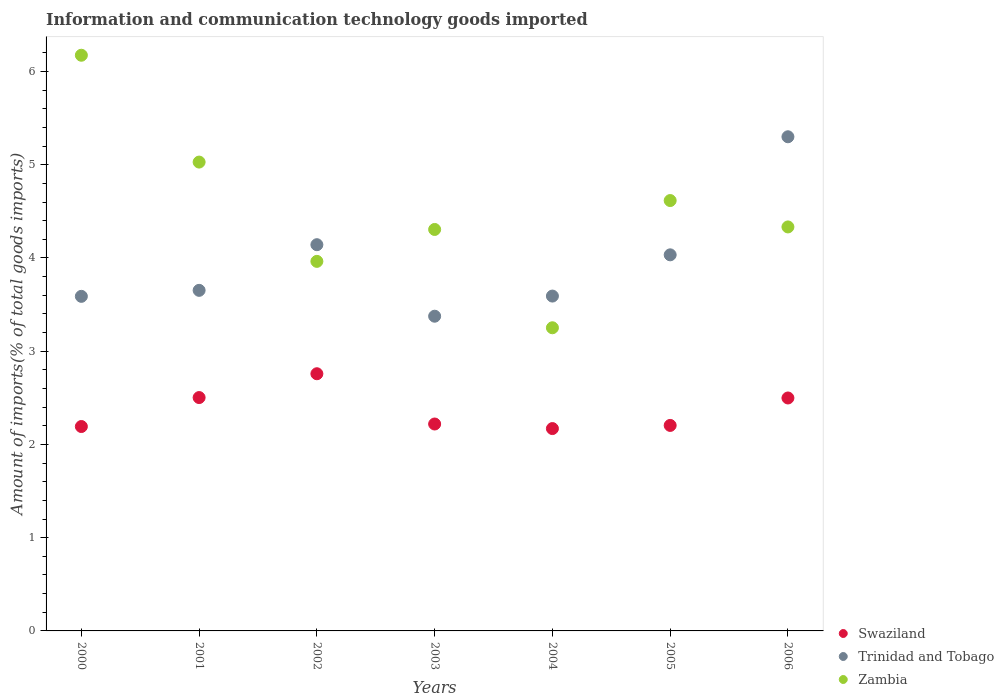How many different coloured dotlines are there?
Your answer should be very brief. 3. What is the amount of goods imported in Zambia in 2005?
Give a very brief answer. 4.62. Across all years, what is the maximum amount of goods imported in Trinidad and Tobago?
Keep it short and to the point. 5.3. Across all years, what is the minimum amount of goods imported in Zambia?
Your response must be concise. 3.25. In which year was the amount of goods imported in Zambia minimum?
Provide a short and direct response. 2004. What is the total amount of goods imported in Swaziland in the graph?
Your answer should be compact. 16.55. What is the difference between the amount of goods imported in Trinidad and Tobago in 2002 and that in 2003?
Give a very brief answer. 0.77. What is the difference between the amount of goods imported in Zambia in 2004 and the amount of goods imported in Swaziland in 2001?
Provide a short and direct response. 0.75. What is the average amount of goods imported in Zambia per year?
Make the answer very short. 4.52. In the year 2004, what is the difference between the amount of goods imported in Zambia and amount of goods imported in Trinidad and Tobago?
Offer a terse response. -0.34. What is the ratio of the amount of goods imported in Zambia in 2003 to that in 2004?
Offer a very short reply. 1.32. What is the difference between the highest and the second highest amount of goods imported in Zambia?
Offer a terse response. 1.15. What is the difference between the highest and the lowest amount of goods imported in Zambia?
Provide a succinct answer. 2.92. In how many years, is the amount of goods imported in Swaziland greater than the average amount of goods imported in Swaziland taken over all years?
Keep it short and to the point. 3. Is the amount of goods imported in Zambia strictly greater than the amount of goods imported in Trinidad and Tobago over the years?
Make the answer very short. No. Is the amount of goods imported in Trinidad and Tobago strictly less than the amount of goods imported in Zambia over the years?
Your answer should be compact. No. How many years are there in the graph?
Offer a terse response. 7. Are the values on the major ticks of Y-axis written in scientific E-notation?
Ensure brevity in your answer.  No. Where does the legend appear in the graph?
Ensure brevity in your answer.  Bottom right. How are the legend labels stacked?
Your answer should be compact. Vertical. What is the title of the graph?
Your answer should be very brief. Information and communication technology goods imported. Does "Congo (Republic)" appear as one of the legend labels in the graph?
Keep it short and to the point. No. What is the label or title of the Y-axis?
Keep it short and to the point. Amount of imports(% of total goods imports). What is the Amount of imports(% of total goods imports) in Swaziland in 2000?
Offer a terse response. 2.19. What is the Amount of imports(% of total goods imports) in Trinidad and Tobago in 2000?
Ensure brevity in your answer.  3.59. What is the Amount of imports(% of total goods imports) of Zambia in 2000?
Your answer should be compact. 6.17. What is the Amount of imports(% of total goods imports) in Swaziland in 2001?
Your answer should be compact. 2.5. What is the Amount of imports(% of total goods imports) of Trinidad and Tobago in 2001?
Provide a short and direct response. 3.65. What is the Amount of imports(% of total goods imports) of Zambia in 2001?
Keep it short and to the point. 5.03. What is the Amount of imports(% of total goods imports) in Swaziland in 2002?
Your answer should be compact. 2.76. What is the Amount of imports(% of total goods imports) of Trinidad and Tobago in 2002?
Your answer should be very brief. 4.14. What is the Amount of imports(% of total goods imports) in Zambia in 2002?
Give a very brief answer. 3.96. What is the Amount of imports(% of total goods imports) of Swaziland in 2003?
Provide a short and direct response. 2.22. What is the Amount of imports(% of total goods imports) in Trinidad and Tobago in 2003?
Offer a terse response. 3.38. What is the Amount of imports(% of total goods imports) of Zambia in 2003?
Ensure brevity in your answer.  4.31. What is the Amount of imports(% of total goods imports) in Swaziland in 2004?
Keep it short and to the point. 2.17. What is the Amount of imports(% of total goods imports) in Trinidad and Tobago in 2004?
Give a very brief answer. 3.59. What is the Amount of imports(% of total goods imports) in Zambia in 2004?
Make the answer very short. 3.25. What is the Amount of imports(% of total goods imports) of Swaziland in 2005?
Your answer should be compact. 2.2. What is the Amount of imports(% of total goods imports) in Trinidad and Tobago in 2005?
Ensure brevity in your answer.  4.03. What is the Amount of imports(% of total goods imports) in Zambia in 2005?
Give a very brief answer. 4.62. What is the Amount of imports(% of total goods imports) of Swaziland in 2006?
Provide a short and direct response. 2.5. What is the Amount of imports(% of total goods imports) in Trinidad and Tobago in 2006?
Ensure brevity in your answer.  5.3. What is the Amount of imports(% of total goods imports) of Zambia in 2006?
Offer a terse response. 4.33. Across all years, what is the maximum Amount of imports(% of total goods imports) in Swaziland?
Make the answer very short. 2.76. Across all years, what is the maximum Amount of imports(% of total goods imports) in Trinidad and Tobago?
Your response must be concise. 5.3. Across all years, what is the maximum Amount of imports(% of total goods imports) in Zambia?
Your answer should be very brief. 6.17. Across all years, what is the minimum Amount of imports(% of total goods imports) in Swaziland?
Give a very brief answer. 2.17. Across all years, what is the minimum Amount of imports(% of total goods imports) in Trinidad and Tobago?
Make the answer very short. 3.38. Across all years, what is the minimum Amount of imports(% of total goods imports) of Zambia?
Ensure brevity in your answer.  3.25. What is the total Amount of imports(% of total goods imports) in Swaziland in the graph?
Provide a succinct answer. 16.55. What is the total Amount of imports(% of total goods imports) in Trinidad and Tobago in the graph?
Make the answer very short. 27.68. What is the total Amount of imports(% of total goods imports) of Zambia in the graph?
Your answer should be very brief. 31.67. What is the difference between the Amount of imports(% of total goods imports) in Swaziland in 2000 and that in 2001?
Keep it short and to the point. -0.31. What is the difference between the Amount of imports(% of total goods imports) in Trinidad and Tobago in 2000 and that in 2001?
Offer a terse response. -0.06. What is the difference between the Amount of imports(% of total goods imports) in Zambia in 2000 and that in 2001?
Offer a terse response. 1.15. What is the difference between the Amount of imports(% of total goods imports) of Swaziland in 2000 and that in 2002?
Your response must be concise. -0.57. What is the difference between the Amount of imports(% of total goods imports) in Trinidad and Tobago in 2000 and that in 2002?
Your answer should be very brief. -0.55. What is the difference between the Amount of imports(% of total goods imports) of Zambia in 2000 and that in 2002?
Your response must be concise. 2.21. What is the difference between the Amount of imports(% of total goods imports) of Swaziland in 2000 and that in 2003?
Provide a succinct answer. -0.03. What is the difference between the Amount of imports(% of total goods imports) in Trinidad and Tobago in 2000 and that in 2003?
Keep it short and to the point. 0.21. What is the difference between the Amount of imports(% of total goods imports) of Zambia in 2000 and that in 2003?
Your answer should be compact. 1.87. What is the difference between the Amount of imports(% of total goods imports) in Swaziland in 2000 and that in 2004?
Provide a short and direct response. 0.02. What is the difference between the Amount of imports(% of total goods imports) in Trinidad and Tobago in 2000 and that in 2004?
Provide a short and direct response. -0. What is the difference between the Amount of imports(% of total goods imports) of Zambia in 2000 and that in 2004?
Make the answer very short. 2.92. What is the difference between the Amount of imports(% of total goods imports) of Swaziland in 2000 and that in 2005?
Give a very brief answer. -0.01. What is the difference between the Amount of imports(% of total goods imports) in Trinidad and Tobago in 2000 and that in 2005?
Offer a very short reply. -0.45. What is the difference between the Amount of imports(% of total goods imports) of Zambia in 2000 and that in 2005?
Your response must be concise. 1.56. What is the difference between the Amount of imports(% of total goods imports) in Swaziland in 2000 and that in 2006?
Keep it short and to the point. -0.31. What is the difference between the Amount of imports(% of total goods imports) of Trinidad and Tobago in 2000 and that in 2006?
Provide a succinct answer. -1.71. What is the difference between the Amount of imports(% of total goods imports) of Zambia in 2000 and that in 2006?
Ensure brevity in your answer.  1.84. What is the difference between the Amount of imports(% of total goods imports) of Swaziland in 2001 and that in 2002?
Your answer should be compact. -0.26. What is the difference between the Amount of imports(% of total goods imports) in Trinidad and Tobago in 2001 and that in 2002?
Your answer should be compact. -0.49. What is the difference between the Amount of imports(% of total goods imports) of Zambia in 2001 and that in 2002?
Ensure brevity in your answer.  1.06. What is the difference between the Amount of imports(% of total goods imports) of Swaziland in 2001 and that in 2003?
Provide a succinct answer. 0.28. What is the difference between the Amount of imports(% of total goods imports) in Trinidad and Tobago in 2001 and that in 2003?
Ensure brevity in your answer.  0.28. What is the difference between the Amount of imports(% of total goods imports) of Zambia in 2001 and that in 2003?
Provide a short and direct response. 0.72. What is the difference between the Amount of imports(% of total goods imports) in Swaziland in 2001 and that in 2004?
Keep it short and to the point. 0.33. What is the difference between the Amount of imports(% of total goods imports) of Trinidad and Tobago in 2001 and that in 2004?
Give a very brief answer. 0.06. What is the difference between the Amount of imports(% of total goods imports) of Zambia in 2001 and that in 2004?
Your answer should be compact. 1.78. What is the difference between the Amount of imports(% of total goods imports) in Swaziland in 2001 and that in 2005?
Ensure brevity in your answer.  0.3. What is the difference between the Amount of imports(% of total goods imports) of Trinidad and Tobago in 2001 and that in 2005?
Offer a terse response. -0.38. What is the difference between the Amount of imports(% of total goods imports) of Zambia in 2001 and that in 2005?
Your answer should be very brief. 0.41. What is the difference between the Amount of imports(% of total goods imports) of Swaziland in 2001 and that in 2006?
Give a very brief answer. 0. What is the difference between the Amount of imports(% of total goods imports) of Trinidad and Tobago in 2001 and that in 2006?
Your response must be concise. -1.65. What is the difference between the Amount of imports(% of total goods imports) in Zambia in 2001 and that in 2006?
Offer a very short reply. 0.7. What is the difference between the Amount of imports(% of total goods imports) of Swaziland in 2002 and that in 2003?
Provide a short and direct response. 0.54. What is the difference between the Amount of imports(% of total goods imports) of Trinidad and Tobago in 2002 and that in 2003?
Your answer should be very brief. 0.77. What is the difference between the Amount of imports(% of total goods imports) of Zambia in 2002 and that in 2003?
Ensure brevity in your answer.  -0.34. What is the difference between the Amount of imports(% of total goods imports) in Swaziland in 2002 and that in 2004?
Provide a short and direct response. 0.59. What is the difference between the Amount of imports(% of total goods imports) in Trinidad and Tobago in 2002 and that in 2004?
Your answer should be compact. 0.55. What is the difference between the Amount of imports(% of total goods imports) in Zambia in 2002 and that in 2004?
Your answer should be very brief. 0.71. What is the difference between the Amount of imports(% of total goods imports) of Swaziland in 2002 and that in 2005?
Give a very brief answer. 0.55. What is the difference between the Amount of imports(% of total goods imports) in Trinidad and Tobago in 2002 and that in 2005?
Your answer should be compact. 0.11. What is the difference between the Amount of imports(% of total goods imports) of Zambia in 2002 and that in 2005?
Your answer should be compact. -0.65. What is the difference between the Amount of imports(% of total goods imports) in Swaziland in 2002 and that in 2006?
Offer a terse response. 0.26. What is the difference between the Amount of imports(% of total goods imports) in Trinidad and Tobago in 2002 and that in 2006?
Give a very brief answer. -1.16. What is the difference between the Amount of imports(% of total goods imports) in Zambia in 2002 and that in 2006?
Your response must be concise. -0.37. What is the difference between the Amount of imports(% of total goods imports) in Swaziland in 2003 and that in 2004?
Your answer should be compact. 0.05. What is the difference between the Amount of imports(% of total goods imports) in Trinidad and Tobago in 2003 and that in 2004?
Your answer should be very brief. -0.22. What is the difference between the Amount of imports(% of total goods imports) of Zambia in 2003 and that in 2004?
Ensure brevity in your answer.  1.05. What is the difference between the Amount of imports(% of total goods imports) in Swaziland in 2003 and that in 2005?
Provide a succinct answer. 0.02. What is the difference between the Amount of imports(% of total goods imports) of Trinidad and Tobago in 2003 and that in 2005?
Your answer should be very brief. -0.66. What is the difference between the Amount of imports(% of total goods imports) of Zambia in 2003 and that in 2005?
Offer a terse response. -0.31. What is the difference between the Amount of imports(% of total goods imports) in Swaziland in 2003 and that in 2006?
Keep it short and to the point. -0.28. What is the difference between the Amount of imports(% of total goods imports) of Trinidad and Tobago in 2003 and that in 2006?
Your answer should be compact. -1.92. What is the difference between the Amount of imports(% of total goods imports) in Zambia in 2003 and that in 2006?
Your answer should be compact. -0.03. What is the difference between the Amount of imports(% of total goods imports) in Swaziland in 2004 and that in 2005?
Your response must be concise. -0.03. What is the difference between the Amount of imports(% of total goods imports) in Trinidad and Tobago in 2004 and that in 2005?
Provide a succinct answer. -0.44. What is the difference between the Amount of imports(% of total goods imports) in Zambia in 2004 and that in 2005?
Give a very brief answer. -1.36. What is the difference between the Amount of imports(% of total goods imports) of Swaziland in 2004 and that in 2006?
Provide a succinct answer. -0.33. What is the difference between the Amount of imports(% of total goods imports) in Trinidad and Tobago in 2004 and that in 2006?
Give a very brief answer. -1.71. What is the difference between the Amount of imports(% of total goods imports) of Zambia in 2004 and that in 2006?
Provide a short and direct response. -1.08. What is the difference between the Amount of imports(% of total goods imports) of Swaziland in 2005 and that in 2006?
Your answer should be very brief. -0.29. What is the difference between the Amount of imports(% of total goods imports) of Trinidad and Tobago in 2005 and that in 2006?
Keep it short and to the point. -1.27. What is the difference between the Amount of imports(% of total goods imports) in Zambia in 2005 and that in 2006?
Ensure brevity in your answer.  0.28. What is the difference between the Amount of imports(% of total goods imports) of Swaziland in 2000 and the Amount of imports(% of total goods imports) of Trinidad and Tobago in 2001?
Ensure brevity in your answer.  -1.46. What is the difference between the Amount of imports(% of total goods imports) in Swaziland in 2000 and the Amount of imports(% of total goods imports) in Zambia in 2001?
Your answer should be compact. -2.84. What is the difference between the Amount of imports(% of total goods imports) in Trinidad and Tobago in 2000 and the Amount of imports(% of total goods imports) in Zambia in 2001?
Your answer should be very brief. -1.44. What is the difference between the Amount of imports(% of total goods imports) of Swaziland in 2000 and the Amount of imports(% of total goods imports) of Trinidad and Tobago in 2002?
Your answer should be compact. -1.95. What is the difference between the Amount of imports(% of total goods imports) of Swaziland in 2000 and the Amount of imports(% of total goods imports) of Zambia in 2002?
Provide a short and direct response. -1.77. What is the difference between the Amount of imports(% of total goods imports) in Trinidad and Tobago in 2000 and the Amount of imports(% of total goods imports) in Zambia in 2002?
Your answer should be compact. -0.38. What is the difference between the Amount of imports(% of total goods imports) of Swaziland in 2000 and the Amount of imports(% of total goods imports) of Trinidad and Tobago in 2003?
Ensure brevity in your answer.  -1.18. What is the difference between the Amount of imports(% of total goods imports) in Swaziland in 2000 and the Amount of imports(% of total goods imports) in Zambia in 2003?
Give a very brief answer. -2.11. What is the difference between the Amount of imports(% of total goods imports) of Trinidad and Tobago in 2000 and the Amount of imports(% of total goods imports) of Zambia in 2003?
Your answer should be compact. -0.72. What is the difference between the Amount of imports(% of total goods imports) in Swaziland in 2000 and the Amount of imports(% of total goods imports) in Trinidad and Tobago in 2004?
Keep it short and to the point. -1.4. What is the difference between the Amount of imports(% of total goods imports) in Swaziland in 2000 and the Amount of imports(% of total goods imports) in Zambia in 2004?
Offer a terse response. -1.06. What is the difference between the Amount of imports(% of total goods imports) of Trinidad and Tobago in 2000 and the Amount of imports(% of total goods imports) of Zambia in 2004?
Keep it short and to the point. 0.34. What is the difference between the Amount of imports(% of total goods imports) in Swaziland in 2000 and the Amount of imports(% of total goods imports) in Trinidad and Tobago in 2005?
Your answer should be very brief. -1.84. What is the difference between the Amount of imports(% of total goods imports) in Swaziland in 2000 and the Amount of imports(% of total goods imports) in Zambia in 2005?
Your answer should be very brief. -2.42. What is the difference between the Amount of imports(% of total goods imports) in Trinidad and Tobago in 2000 and the Amount of imports(% of total goods imports) in Zambia in 2005?
Make the answer very short. -1.03. What is the difference between the Amount of imports(% of total goods imports) of Swaziland in 2000 and the Amount of imports(% of total goods imports) of Trinidad and Tobago in 2006?
Provide a short and direct response. -3.11. What is the difference between the Amount of imports(% of total goods imports) in Swaziland in 2000 and the Amount of imports(% of total goods imports) in Zambia in 2006?
Your answer should be very brief. -2.14. What is the difference between the Amount of imports(% of total goods imports) in Trinidad and Tobago in 2000 and the Amount of imports(% of total goods imports) in Zambia in 2006?
Offer a terse response. -0.74. What is the difference between the Amount of imports(% of total goods imports) of Swaziland in 2001 and the Amount of imports(% of total goods imports) of Trinidad and Tobago in 2002?
Keep it short and to the point. -1.64. What is the difference between the Amount of imports(% of total goods imports) of Swaziland in 2001 and the Amount of imports(% of total goods imports) of Zambia in 2002?
Your answer should be compact. -1.46. What is the difference between the Amount of imports(% of total goods imports) in Trinidad and Tobago in 2001 and the Amount of imports(% of total goods imports) in Zambia in 2002?
Offer a terse response. -0.31. What is the difference between the Amount of imports(% of total goods imports) of Swaziland in 2001 and the Amount of imports(% of total goods imports) of Trinidad and Tobago in 2003?
Provide a succinct answer. -0.87. What is the difference between the Amount of imports(% of total goods imports) of Swaziland in 2001 and the Amount of imports(% of total goods imports) of Zambia in 2003?
Your answer should be compact. -1.8. What is the difference between the Amount of imports(% of total goods imports) of Trinidad and Tobago in 2001 and the Amount of imports(% of total goods imports) of Zambia in 2003?
Your answer should be compact. -0.65. What is the difference between the Amount of imports(% of total goods imports) of Swaziland in 2001 and the Amount of imports(% of total goods imports) of Trinidad and Tobago in 2004?
Provide a short and direct response. -1.09. What is the difference between the Amount of imports(% of total goods imports) of Swaziland in 2001 and the Amount of imports(% of total goods imports) of Zambia in 2004?
Offer a very short reply. -0.75. What is the difference between the Amount of imports(% of total goods imports) in Trinidad and Tobago in 2001 and the Amount of imports(% of total goods imports) in Zambia in 2004?
Offer a very short reply. 0.4. What is the difference between the Amount of imports(% of total goods imports) in Swaziland in 2001 and the Amount of imports(% of total goods imports) in Trinidad and Tobago in 2005?
Provide a short and direct response. -1.53. What is the difference between the Amount of imports(% of total goods imports) in Swaziland in 2001 and the Amount of imports(% of total goods imports) in Zambia in 2005?
Provide a short and direct response. -2.11. What is the difference between the Amount of imports(% of total goods imports) in Trinidad and Tobago in 2001 and the Amount of imports(% of total goods imports) in Zambia in 2005?
Give a very brief answer. -0.96. What is the difference between the Amount of imports(% of total goods imports) in Swaziland in 2001 and the Amount of imports(% of total goods imports) in Trinidad and Tobago in 2006?
Ensure brevity in your answer.  -2.8. What is the difference between the Amount of imports(% of total goods imports) in Swaziland in 2001 and the Amount of imports(% of total goods imports) in Zambia in 2006?
Offer a very short reply. -1.83. What is the difference between the Amount of imports(% of total goods imports) of Trinidad and Tobago in 2001 and the Amount of imports(% of total goods imports) of Zambia in 2006?
Your answer should be very brief. -0.68. What is the difference between the Amount of imports(% of total goods imports) in Swaziland in 2002 and the Amount of imports(% of total goods imports) in Trinidad and Tobago in 2003?
Keep it short and to the point. -0.62. What is the difference between the Amount of imports(% of total goods imports) of Swaziland in 2002 and the Amount of imports(% of total goods imports) of Zambia in 2003?
Offer a very short reply. -1.55. What is the difference between the Amount of imports(% of total goods imports) in Trinidad and Tobago in 2002 and the Amount of imports(% of total goods imports) in Zambia in 2003?
Offer a terse response. -0.16. What is the difference between the Amount of imports(% of total goods imports) in Swaziland in 2002 and the Amount of imports(% of total goods imports) in Trinidad and Tobago in 2004?
Offer a very short reply. -0.83. What is the difference between the Amount of imports(% of total goods imports) of Swaziland in 2002 and the Amount of imports(% of total goods imports) of Zambia in 2004?
Ensure brevity in your answer.  -0.49. What is the difference between the Amount of imports(% of total goods imports) in Trinidad and Tobago in 2002 and the Amount of imports(% of total goods imports) in Zambia in 2004?
Keep it short and to the point. 0.89. What is the difference between the Amount of imports(% of total goods imports) in Swaziland in 2002 and the Amount of imports(% of total goods imports) in Trinidad and Tobago in 2005?
Your answer should be compact. -1.28. What is the difference between the Amount of imports(% of total goods imports) of Swaziland in 2002 and the Amount of imports(% of total goods imports) of Zambia in 2005?
Make the answer very short. -1.86. What is the difference between the Amount of imports(% of total goods imports) in Trinidad and Tobago in 2002 and the Amount of imports(% of total goods imports) in Zambia in 2005?
Provide a succinct answer. -0.47. What is the difference between the Amount of imports(% of total goods imports) in Swaziland in 2002 and the Amount of imports(% of total goods imports) in Trinidad and Tobago in 2006?
Ensure brevity in your answer.  -2.54. What is the difference between the Amount of imports(% of total goods imports) of Swaziland in 2002 and the Amount of imports(% of total goods imports) of Zambia in 2006?
Give a very brief answer. -1.57. What is the difference between the Amount of imports(% of total goods imports) in Trinidad and Tobago in 2002 and the Amount of imports(% of total goods imports) in Zambia in 2006?
Your answer should be very brief. -0.19. What is the difference between the Amount of imports(% of total goods imports) of Swaziland in 2003 and the Amount of imports(% of total goods imports) of Trinidad and Tobago in 2004?
Make the answer very short. -1.37. What is the difference between the Amount of imports(% of total goods imports) of Swaziland in 2003 and the Amount of imports(% of total goods imports) of Zambia in 2004?
Your answer should be compact. -1.03. What is the difference between the Amount of imports(% of total goods imports) of Trinidad and Tobago in 2003 and the Amount of imports(% of total goods imports) of Zambia in 2004?
Provide a short and direct response. 0.12. What is the difference between the Amount of imports(% of total goods imports) of Swaziland in 2003 and the Amount of imports(% of total goods imports) of Trinidad and Tobago in 2005?
Ensure brevity in your answer.  -1.81. What is the difference between the Amount of imports(% of total goods imports) of Swaziland in 2003 and the Amount of imports(% of total goods imports) of Zambia in 2005?
Your answer should be compact. -2.4. What is the difference between the Amount of imports(% of total goods imports) of Trinidad and Tobago in 2003 and the Amount of imports(% of total goods imports) of Zambia in 2005?
Give a very brief answer. -1.24. What is the difference between the Amount of imports(% of total goods imports) in Swaziland in 2003 and the Amount of imports(% of total goods imports) in Trinidad and Tobago in 2006?
Provide a succinct answer. -3.08. What is the difference between the Amount of imports(% of total goods imports) in Swaziland in 2003 and the Amount of imports(% of total goods imports) in Zambia in 2006?
Your response must be concise. -2.11. What is the difference between the Amount of imports(% of total goods imports) in Trinidad and Tobago in 2003 and the Amount of imports(% of total goods imports) in Zambia in 2006?
Your response must be concise. -0.96. What is the difference between the Amount of imports(% of total goods imports) in Swaziland in 2004 and the Amount of imports(% of total goods imports) in Trinidad and Tobago in 2005?
Your answer should be compact. -1.86. What is the difference between the Amount of imports(% of total goods imports) of Swaziland in 2004 and the Amount of imports(% of total goods imports) of Zambia in 2005?
Ensure brevity in your answer.  -2.45. What is the difference between the Amount of imports(% of total goods imports) of Trinidad and Tobago in 2004 and the Amount of imports(% of total goods imports) of Zambia in 2005?
Offer a very short reply. -1.02. What is the difference between the Amount of imports(% of total goods imports) of Swaziland in 2004 and the Amount of imports(% of total goods imports) of Trinidad and Tobago in 2006?
Your answer should be compact. -3.13. What is the difference between the Amount of imports(% of total goods imports) in Swaziland in 2004 and the Amount of imports(% of total goods imports) in Zambia in 2006?
Ensure brevity in your answer.  -2.16. What is the difference between the Amount of imports(% of total goods imports) in Trinidad and Tobago in 2004 and the Amount of imports(% of total goods imports) in Zambia in 2006?
Give a very brief answer. -0.74. What is the difference between the Amount of imports(% of total goods imports) of Swaziland in 2005 and the Amount of imports(% of total goods imports) of Trinidad and Tobago in 2006?
Your answer should be compact. -3.1. What is the difference between the Amount of imports(% of total goods imports) of Swaziland in 2005 and the Amount of imports(% of total goods imports) of Zambia in 2006?
Offer a terse response. -2.13. What is the difference between the Amount of imports(% of total goods imports) in Trinidad and Tobago in 2005 and the Amount of imports(% of total goods imports) in Zambia in 2006?
Provide a short and direct response. -0.3. What is the average Amount of imports(% of total goods imports) of Swaziland per year?
Offer a very short reply. 2.36. What is the average Amount of imports(% of total goods imports) of Trinidad and Tobago per year?
Provide a succinct answer. 3.95. What is the average Amount of imports(% of total goods imports) in Zambia per year?
Provide a short and direct response. 4.52. In the year 2000, what is the difference between the Amount of imports(% of total goods imports) of Swaziland and Amount of imports(% of total goods imports) of Trinidad and Tobago?
Your answer should be compact. -1.4. In the year 2000, what is the difference between the Amount of imports(% of total goods imports) in Swaziland and Amount of imports(% of total goods imports) in Zambia?
Provide a short and direct response. -3.98. In the year 2000, what is the difference between the Amount of imports(% of total goods imports) of Trinidad and Tobago and Amount of imports(% of total goods imports) of Zambia?
Provide a succinct answer. -2.59. In the year 2001, what is the difference between the Amount of imports(% of total goods imports) of Swaziland and Amount of imports(% of total goods imports) of Trinidad and Tobago?
Your answer should be very brief. -1.15. In the year 2001, what is the difference between the Amount of imports(% of total goods imports) in Swaziland and Amount of imports(% of total goods imports) in Zambia?
Your answer should be compact. -2.53. In the year 2001, what is the difference between the Amount of imports(% of total goods imports) of Trinidad and Tobago and Amount of imports(% of total goods imports) of Zambia?
Offer a very short reply. -1.38. In the year 2002, what is the difference between the Amount of imports(% of total goods imports) in Swaziland and Amount of imports(% of total goods imports) in Trinidad and Tobago?
Your answer should be compact. -1.38. In the year 2002, what is the difference between the Amount of imports(% of total goods imports) in Swaziland and Amount of imports(% of total goods imports) in Zambia?
Offer a very short reply. -1.21. In the year 2002, what is the difference between the Amount of imports(% of total goods imports) of Trinidad and Tobago and Amount of imports(% of total goods imports) of Zambia?
Your answer should be very brief. 0.18. In the year 2003, what is the difference between the Amount of imports(% of total goods imports) in Swaziland and Amount of imports(% of total goods imports) in Trinidad and Tobago?
Provide a succinct answer. -1.16. In the year 2003, what is the difference between the Amount of imports(% of total goods imports) in Swaziland and Amount of imports(% of total goods imports) in Zambia?
Provide a succinct answer. -2.09. In the year 2003, what is the difference between the Amount of imports(% of total goods imports) of Trinidad and Tobago and Amount of imports(% of total goods imports) of Zambia?
Provide a succinct answer. -0.93. In the year 2004, what is the difference between the Amount of imports(% of total goods imports) of Swaziland and Amount of imports(% of total goods imports) of Trinidad and Tobago?
Make the answer very short. -1.42. In the year 2004, what is the difference between the Amount of imports(% of total goods imports) of Swaziland and Amount of imports(% of total goods imports) of Zambia?
Your response must be concise. -1.08. In the year 2004, what is the difference between the Amount of imports(% of total goods imports) in Trinidad and Tobago and Amount of imports(% of total goods imports) in Zambia?
Your response must be concise. 0.34. In the year 2005, what is the difference between the Amount of imports(% of total goods imports) of Swaziland and Amount of imports(% of total goods imports) of Trinidad and Tobago?
Your answer should be compact. -1.83. In the year 2005, what is the difference between the Amount of imports(% of total goods imports) of Swaziland and Amount of imports(% of total goods imports) of Zambia?
Give a very brief answer. -2.41. In the year 2005, what is the difference between the Amount of imports(% of total goods imports) of Trinidad and Tobago and Amount of imports(% of total goods imports) of Zambia?
Provide a short and direct response. -0.58. In the year 2006, what is the difference between the Amount of imports(% of total goods imports) of Swaziland and Amount of imports(% of total goods imports) of Trinidad and Tobago?
Your answer should be compact. -2.8. In the year 2006, what is the difference between the Amount of imports(% of total goods imports) in Swaziland and Amount of imports(% of total goods imports) in Zambia?
Make the answer very short. -1.83. In the year 2006, what is the difference between the Amount of imports(% of total goods imports) of Trinidad and Tobago and Amount of imports(% of total goods imports) of Zambia?
Offer a terse response. 0.97. What is the ratio of the Amount of imports(% of total goods imports) of Swaziland in 2000 to that in 2001?
Make the answer very short. 0.88. What is the ratio of the Amount of imports(% of total goods imports) in Trinidad and Tobago in 2000 to that in 2001?
Your answer should be compact. 0.98. What is the ratio of the Amount of imports(% of total goods imports) of Zambia in 2000 to that in 2001?
Give a very brief answer. 1.23. What is the ratio of the Amount of imports(% of total goods imports) of Swaziland in 2000 to that in 2002?
Give a very brief answer. 0.79. What is the ratio of the Amount of imports(% of total goods imports) in Trinidad and Tobago in 2000 to that in 2002?
Provide a short and direct response. 0.87. What is the ratio of the Amount of imports(% of total goods imports) in Zambia in 2000 to that in 2002?
Your answer should be compact. 1.56. What is the ratio of the Amount of imports(% of total goods imports) of Trinidad and Tobago in 2000 to that in 2003?
Offer a terse response. 1.06. What is the ratio of the Amount of imports(% of total goods imports) in Zambia in 2000 to that in 2003?
Keep it short and to the point. 1.43. What is the ratio of the Amount of imports(% of total goods imports) in Swaziland in 2000 to that in 2004?
Offer a terse response. 1.01. What is the ratio of the Amount of imports(% of total goods imports) in Zambia in 2000 to that in 2004?
Your answer should be compact. 1.9. What is the ratio of the Amount of imports(% of total goods imports) of Swaziland in 2000 to that in 2005?
Your response must be concise. 0.99. What is the ratio of the Amount of imports(% of total goods imports) in Trinidad and Tobago in 2000 to that in 2005?
Keep it short and to the point. 0.89. What is the ratio of the Amount of imports(% of total goods imports) of Zambia in 2000 to that in 2005?
Provide a short and direct response. 1.34. What is the ratio of the Amount of imports(% of total goods imports) of Swaziland in 2000 to that in 2006?
Give a very brief answer. 0.88. What is the ratio of the Amount of imports(% of total goods imports) of Trinidad and Tobago in 2000 to that in 2006?
Ensure brevity in your answer.  0.68. What is the ratio of the Amount of imports(% of total goods imports) of Zambia in 2000 to that in 2006?
Provide a short and direct response. 1.43. What is the ratio of the Amount of imports(% of total goods imports) in Swaziland in 2001 to that in 2002?
Make the answer very short. 0.91. What is the ratio of the Amount of imports(% of total goods imports) of Trinidad and Tobago in 2001 to that in 2002?
Your answer should be compact. 0.88. What is the ratio of the Amount of imports(% of total goods imports) in Zambia in 2001 to that in 2002?
Keep it short and to the point. 1.27. What is the ratio of the Amount of imports(% of total goods imports) in Swaziland in 2001 to that in 2003?
Make the answer very short. 1.13. What is the ratio of the Amount of imports(% of total goods imports) in Trinidad and Tobago in 2001 to that in 2003?
Your answer should be very brief. 1.08. What is the ratio of the Amount of imports(% of total goods imports) of Zambia in 2001 to that in 2003?
Your response must be concise. 1.17. What is the ratio of the Amount of imports(% of total goods imports) in Swaziland in 2001 to that in 2004?
Offer a very short reply. 1.15. What is the ratio of the Amount of imports(% of total goods imports) of Trinidad and Tobago in 2001 to that in 2004?
Your answer should be compact. 1.02. What is the ratio of the Amount of imports(% of total goods imports) of Zambia in 2001 to that in 2004?
Make the answer very short. 1.55. What is the ratio of the Amount of imports(% of total goods imports) in Swaziland in 2001 to that in 2005?
Your answer should be very brief. 1.14. What is the ratio of the Amount of imports(% of total goods imports) in Trinidad and Tobago in 2001 to that in 2005?
Offer a terse response. 0.91. What is the ratio of the Amount of imports(% of total goods imports) in Zambia in 2001 to that in 2005?
Make the answer very short. 1.09. What is the ratio of the Amount of imports(% of total goods imports) of Trinidad and Tobago in 2001 to that in 2006?
Your answer should be compact. 0.69. What is the ratio of the Amount of imports(% of total goods imports) in Zambia in 2001 to that in 2006?
Your response must be concise. 1.16. What is the ratio of the Amount of imports(% of total goods imports) of Swaziland in 2002 to that in 2003?
Your answer should be compact. 1.24. What is the ratio of the Amount of imports(% of total goods imports) in Trinidad and Tobago in 2002 to that in 2003?
Your answer should be compact. 1.23. What is the ratio of the Amount of imports(% of total goods imports) of Zambia in 2002 to that in 2003?
Keep it short and to the point. 0.92. What is the ratio of the Amount of imports(% of total goods imports) in Swaziland in 2002 to that in 2004?
Ensure brevity in your answer.  1.27. What is the ratio of the Amount of imports(% of total goods imports) of Trinidad and Tobago in 2002 to that in 2004?
Offer a very short reply. 1.15. What is the ratio of the Amount of imports(% of total goods imports) of Zambia in 2002 to that in 2004?
Give a very brief answer. 1.22. What is the ratio of the Amount of imports(% of total goods imports) in Swaziland in 2002 to that in 2005?
Your answer should be compact. 1.25. What is the ratio of the Amount of imports(% of total goods imports) in Zambia in 2002 to that in 2005?
Your answer should be very brief. 0.86. What is the ratio of the Amount of imports(% of total goods imports) of Swaziland in 2002 to that in 2006?
Give a very brief answer. 1.1. What is the ratio of the Amount of imports(% of total goods imports) of Trinidad and Tobago in 2002 to that in 2006?
Make the answer very short. 0.78. What is the ratio of the Amount of imports(% of total goods imports) of Zambia in 2002 to that in 2006?
Provide a short and direct response. 0.91. What is the ratio of the Amount of imports(% of total goods imports) of Swaziland in 2003 to that in 2004?
Provide a succinct answer. 1.02. What is the ratio of the Amount of imports(% of total goods imports) of Trinidad and Tobago in 2003 to that in 2004?
Make the answer very short. 0.94. What is the ratio of the Amount of imports(% of total goods imports) in Zambia in 2003 to that in 2004?
Provide a succinct answer. 1.32. What is the ratio of the Amount of imports(% of total goods imports) in Trinidad and Tobago in 2003 to that in 2005?
Ensure brevity in your answer.  0.84. What is the ratio of the Amount of imports(% of total goods imports) of Zambia in 2003 to that in 2005?
Give a very brief answer. 0.93. What is the ratio of the Amount of imports(% of total goods imports) of Swaziland in 2003 to that in 2006?
Your answer should be very brief. 0.89. What is the ratio of the Amount of imports(% of total goods imports) of Trinidad and Tobago in 2003 to that in 2006?
Provide a succinct answer. 0.64. What is the ratio of the Amount of imports(% of total goods imports) in Zambia in 2003 to that in 2006?
Provide a short and direct response. 0.99. What is the ratio of the Amount of imports(% of total goods imports) in Swaziland in 2004 to that in 2005?
Keep it short and to the point. 0.98. What is the ratio of the Amount of imports(% of total goods imports) of Trinidad and Tobago in 2004 to that in 2005?
Offer a very short reply. 0.89. What is the ratio of the Amount of imports(% of total goods imports) in Zambia in 2004 to that in 2005?
Give a very brief answer. 0.7. What is the ratio of the Amount of imports(% of total goods imports) in Swaziland in 2004 to that in 2006?
Offer a terse response. 0.87. What is the ratio of the Amount of imports(% of total goods imports) of Trinidad and Tobago in 2004 to that in 2006?
Give a very brief answer. 0.68. What is the ratio of the Amount of imports(% of total goods imports) of Zambia in 2004 to that in 2006?
Give a very brief answer. 0.75. What is the ratio of the Amount of imports(% of total goods imports) in Swaziland in 2005 to that in 2006?
Keep it short and to the point. 0.88. What is the ratio of the Amount of imports(% of total goods imports) of Trinidad and Tobago in 2005 to that in 2006?
Your answer should be compact. 0.76. What is the ratio of the Amount of imports(% of total goods imports) in Zambia in 2005 to that in 2006?
Provide a short and direct response. 1.07. What is the difference between the highest and the second highest Amount of imports(% of total goods imports) of Swaziland?
Provide a succinct answer. 0.26. What is the difference between the highest and the second highest Amount of imports(% of total goods imports) of Trinidad and Tobago?
Your answer should be compact. 1.16. What is the difference between the highest and the second highest Amount of imports(% of total goods imports) of Zambia?
Make the answer very short. 1.15. What is the difference between the highest and the lowest Amount of imports(% of total goods imports) of Swaziland?
Give a very brief answer. 0.59. What is the difference between the highest and the lowest Amount of imports(% of total goods imports) of Trinidad and Tobago?
Make the answer very short. 1.92. What is the difference between the highest and the lowest Amount of imports(% of total goods imports) of Zambia?
Offer a terse response. 2.92. 